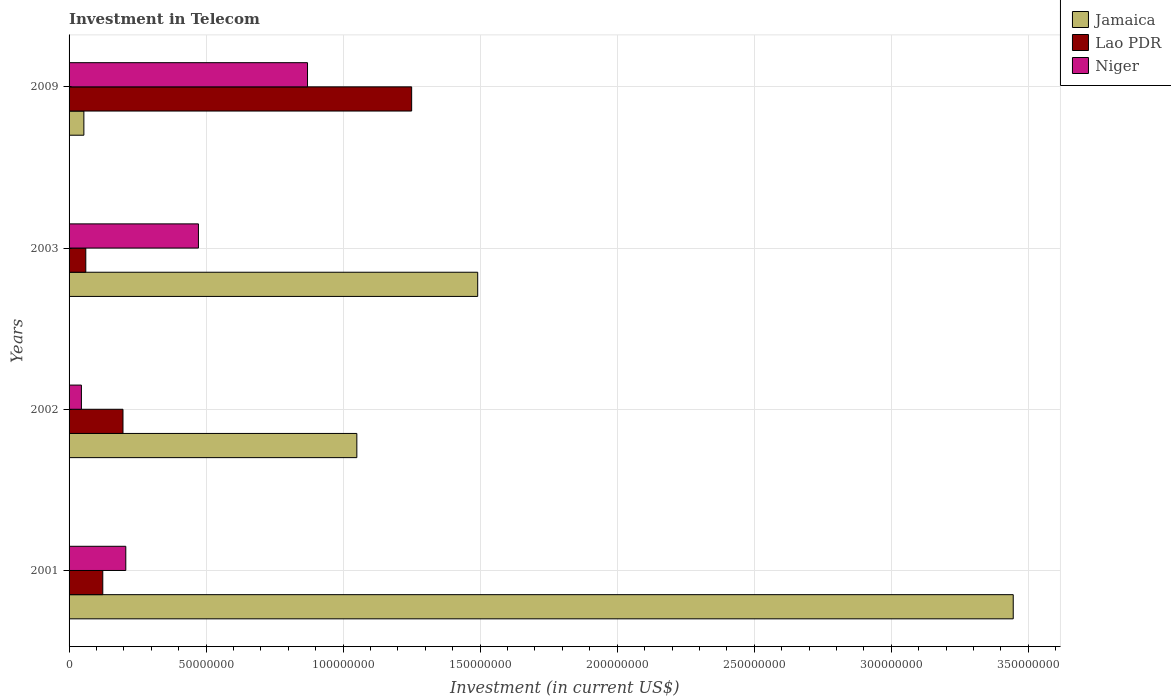How many groups of bars are there?
Keep it short and to the point. 4. How many bars are there on the 1st tick from the top?
Your answer should be very brief. 3. How many bars are there on the 1st tick from the bottom?
Your response must be concise. 3. What is the amount invested in telecom in Niger in 2002?
Make the answer very short. 4.50e+06. Across all years, what is the maximum amount invested in telecom in Jamaica?
Ensure brevity in your answer.  3.44e+08. Across all years, what is the minimum amount invested in telecom in Lao PDR?
Provide a succinct answer. 6.10e+06. What is the total amount invested in telecom in Jamaica in the graph?
Your answer should be very brief. 6.04e+08. What is the difference between the amount invested in telecom in Niger in 2001 and that in 2002?
Make the answer very short. 1.62e+07. What is the difference between the amount invested in telecom in Niger in 2001 and the amount invested in telecom in Lao PDR in 2003?
Provide a short and direct response. 1.46e+07. What is the average amount invested in telecom in Lao PDR per year?
Make the answer very short. 4.08e+07. In the year 2001, what is the difference between the amount invested in telecom in Jamaica and amount invested in telecom in Niger?
Ensure brevity in your answer.  3.24e+08. What is the ratio of the amount invested in telecom in Niger in 2002 to that in 2003?
Make the answer very short. 0.1. Is the amount invested in telecom in Jamaica in 2002 less than that in 2003?
Ensure brevity in your answer.  Yes. What is the difference between the highest and the second highest amount invested in telecom in Niger?
Offer a very short reply. 3.98e+07. What is the difference between the highest and the lowest amount invested in telecom in Niger?
Offer a terse response. 8.25e+07. In how many years, is the amount invested in telecom in Jamaica greater than the average amount invested in telecom in Jamaica taken over all years?
Your response must be concise. 1. Is the sum of the amount invested in telecom in Jamaica in 2001 and 2003 greater than the maximum amount invested in telecom in Lao PDR across all years?
Your answer should be very brief. Yes. What does the 2nd bar from the top in 2003 represents?
Provide a short and direct response. Lao PDR. What does the 2nd bar from the bottom in 2001 represents?
Make the answer very short. Lao PDR. Are all the bars in the graph horizontal?
Your answer should be very brief. Yes. Are the values on the major ticks of X-axis written in scientific E-notation?
Your answer should be very brief. No. Does the graph contain grids?
Give a very brief answer. Yes. What is the title of the graph?
Keep it short and to the point. Investment in Telecom. Does "Singapore" appear as one of the legend labels in the graph?
Offer a very short reply. No. What is the label or title of the X-axis?
Your answer should be compact. Investment (in current US$). What is the Investment (in current US$) in Jamaica in 2001?
Your response must be concise. 3.44e+08. What is the Investment (in current US$) of Lao PDR in 2001?
Provide a succinct answer. 1.23e+07. What is the Investment (in current US$) of Niger in 2001?
Give a very brief answer. 2.07e+07. What is the Investment (in current US$) of Jamaica in 2002?
Give a very brief answer. 1.05e+08. What is the Investment (in current US$) in Lao PDR in 2002?
Provide a succinct answer. 1.97e+07. What is the Investment (in current US$) in Niger in 2002?
Keep it short and to the point. 4.50e+06. What is the Investment (in current US$) of Jamaica in 2003?
Ensure brevity in your answer.  1.49e+08. What is the Investment (in current US$) in Lao PDR in 2003?
Provide a short and direct response. 6.10e+06. What is the Investment (in current US$) in Niger in 2003?
Provide a short and direct response. 4.72e+07. What is the Investment (in current US$) of Jamaica in 2009?
Your answer should be very brief. 5.40e+06. What is the Investment (in current US$) of Lao PDR in 2009?
Your response must be concise. 1.25e+08. What is the Investment (in current US$) of Niger in 2009?
Offer a terse response. 8.70e+07. Across all years, what is the maximum Investment (in current US$) in Jamaica?
Your response must be concise. 3.44e+08. Across all years, what is the maximum Investment (in current US$) in Lao PDR?
Your response must be concise. 1.25e+08. Across all years, what is the maximum Investment (in current US$) in Niger?
Ensure brevity in your answer.  8.70e+07. Across all years, what is the minimum Investment (in current US$) in Jamaica?
Your response must be concise. 5.40e+06. Across all years, what is the minimum Investment (in current US$) of Lao PDR?
Give a very brief answer. 6.10e+06. Across all years, what is the minimum Investment (in current US$) in Niger?
Keep it short and to the point. 4.50e+06. What is the total Investment (in current US$) of Jamaica in the graph?
Give a very brief answer. 6.04e+08. What is the total Investment (in current US$) of Lao PDR in the graph?
Your answer should be very brief. 1.63e+08. What is the total Investment (in current US$) in Niger in the graph?
Make the answer very short. 1.59e+08. What is the difference between the Investment (in current US$) in Jamaica in 2001 and that in 2002?
Give a very brief answer. 2.40e+08. What is the difference between the Investment (in current US$) of Lao PDR in 2001 and that in 2002?
Your answer should be compact. -7.37e+06. What is the difference between the Investment (in current US$) of Niger in 2001 and that in 2002?
Provide a succinct answer. 1.62e+07. What is the difference between the Investment (in current US$) in Jamaica in 2001 and that in 2003?
Make the answer very short. 1.95e+08. What is the difference between the Investment (in current US$) in Lao PDR in 2001 and that in 2003?
Provide a succinct answer. 6.20e+06. What is the difference between the Investment (in current US$) in Niger in 2001 and that in 2003?
Make the answer very short. -2.65e+07. What is the difference between the Investment (in current US$) of Jamaica in 2001 and that in 2009?
Offer a terse response. 3.39e+08. What is the difference between the Investment (in current US$) of Lao PDR in 2001 and that in 2009?
Offer a terse response. -1.13e+08. What is the difference between the Investment (in current US$) in Niger in 2001 and that in 2009?
Your answer should be very brief. -6.63e+07. What is the difference between the Investment (in current US$) of Jamaica in 2002 and that in 2003?
Your response must be concise. -4.41e+07. What is the difference between the Investment (in current US$) in Lao PDR in 2002 and that in 2003?
Offer a very short reply. 1.36e+07. What is the difference between the Investment (in current US$) of Niger in 2002 and that in 2003?
Keep it short and to the point. -4.27e+07. What is the difference between the Investment (in current US$) in Jamaica in 2002 and that in 2009?
Give a very brief answer. 9.96e+07. What is the difference between the Investment (in current US$) of Lao PDR in 2002 and that in 2009?
Make the answer very short. -1.05e+08. What is the difference between the Investment (in current US$) in Niger in 2002 and that in 2009?
Keep it short and to the point. -8.25e+07. What is the difference between the Investment (in current US$) of Jamaica in 2003 and that in 2009?
Ensure brevity in your answer.  1.44e+08. What is the difference between the Investment (in current US$) in Lao PDR in 2003 and that in 2009?
Your answer should be very brief. -1.19e+08. What is the difference between the Investment (in current US$) of Niger in 2003 and that in 2009?
Provide a short and direct response. -3.98e+07. What is the difference between the Investment (in current US$) in Jamaica in 2001 and the Investment (in current US$) in Lao PDR in 2002?
Ensure brevity in your answer.  3.25e+08. What is the difference between the Investment (in current US$) of Jamaica in 2001 and the Investment (in current US$) of Niger in 2002?
Provide a succinct answer. 3.40e+08. What is the difference between the Investment (in current US$) of Lao PDR in 2001 and the Investment (in current US$) of Niger in 2002?
Provide a short and direct response. 7.80e+06. What is the difference between the Investment (in current US$) of Jamaica in 2001 and the Investment (in current US$) of Lao PDR in 2003?
Give a very brief answer. 3.38e+08. What is the difference between the Investment (in current US$) of Jamaica in 2001 and the Investment (in current US$) of Niger in 2003?
Your answer should be compact. 2.97e+08. What is the difference between the Investment (in current US$) in Lao PDR in 2001 and the Investment (in current US$) in Niger in 2003?
Keep it short and to the point. -3.49e+07. What is the difference between the Investment (in current US$) of Jamaica in 2001 and the Investment (in current US$) of Lao PDR in 2009?
Provide a succinct answer. 2.20e+08. What is the difference between the Investment (in current US$) in Jamaica in 2001 and the Investment (in current US$) in Niger in 2009?
Offer a terse response. 2.58e+08. What is the difference between the Investment (in current US$) of Lao PDR in 2001 and the Investment (in current US$) of Niger in 2009?
Give a very brief answer. -7.47e+07. What is the difference between the Investment (in current US$) in Jamaica in 2002 and the Investment (in current US$) in Lao PDR in 2003?
Offer a very short reply. 9.89e+07. What is the difference between the Investment (in current US$) in Jamaica in 2002 and the Investment (in current US$) in Niger in 2003?
Your answer should be compact. 5.78e+07. What is the difference between the Investment (in current US$) in Lao PDR in 2002 and the Investment (in current US$) in Niger in 2003?
Your answer should be very brief. -2.75e+07. What is the difference between the Investment (in current US$) of Jamaica in 2002 and the Investment (in current US$) of Lao PDR in 2009?
Make the answer very short. -2.00e+07. What is the difference between the Investment (in current US$) of Jamaica in 2002 and the Investment (in current US$) of Niger in 2009?
Your answer should be compact. 1.80e+07. What is the difference between the Investment (in current US$) of Lao PDR in 2002 and the Investment (in current US$) of Niger in 2009?
Your answer should be compact. -6.73e+07. What is the difference between the Investment (in current US$) in Jamaica in 2003 and the Investment (in current US$) in Lao PDR in 2009?
Provide a succinct answer. 2.41e+07. What is the difference between the Investment (in current US$) in Jamaica in 2003 and the Investment (in current US$) in Niger in 2009?
Provide a short and direct response. 6.21e+07. What is the difference between the Investment (in current US$) in Lao PDR in 2003 and the Investment (in current US$) in Niger in 2009?
Offer a very short reply. -8.09e+07. What is the average Investment (in current US$) of Jamaica per year?
Your answer should be compact. 1.51e+08. What is the average Investment (in current US$) in Lao PDR per year?
Keep it short and to the point. 4.08e+07. What is the average Investment (in current US$) in Niger per year?
Offer a very short reply. 3.98e+07. In the year 2001, what is the difference between the Investment (in current US$) in Jamaica and Investment (in current US$) in Lao PDR?
Your answer should be compact. 3.32e+08. In the year 2001, what is the difference between the Investment (in current US$) of Jamaica and Investment (in current US$) of Niger?
Make the answer very short. 3.24e+08. In the year 2001, what is the difference between the Investment (in current US$) of Lao PDR and Investment (in current US$) of Niger?
Your answer should be very brief. -8.40e+06. In the year 2002, what is the difference between the Investment (in current US$) in Jamaica and Investment (in current US$) in Lao PDR?
Ensure brevity in your answer.  8.53e+07. In the year 2002, what is the difference between the Investment (in current US$) of Jamaica and Investment (in current US$) of Niger?
Offer a very short reply. 1.00e+08. In the year 2002, what is the difference between the Investment (in current US$) of Lao PDR and Investment (in current US$) of Niger?
Your answer should be compact. 1.52e+07. In the year 2003, what is the difference between the Investment (in current US$) of Jamaica and Investment (in current US$) of Lao PDR?
Your response must be concise. 1.43e+08. In the year 2003, what is the difference between the Investment (in current US$) in Jamaica and Investment (in current US$) in Niger?
Your response must be concise. 1.02e+08. In the year 2003, what is the difference between the Investment (in current US$) of Lao PDR and Investment (in current US$) of Niger?
Your response must be concise. -4.11e+07. In the year 2009, what is the difference between the Investment (in current US$) in Jamaica and Investment (in current US$) in Lao PDR?
Ensure brevity in your answer.  -1.20e+08. In the year 2009, what is the difference between the Investment (in current US$) in Jamaica and Investment (in current US$) in Niger?
Ensure brevity in your answer.  -8.16e+07. In the year 2009, what is the difference between the Investment (in current US$) of Lao PDR and Investment (in current US$) of Niger?
Provide a short and direct response. 3.80e+07. What is the ratio of the Investment (in current US$) of Jamaica in 2001 to that in 2002?
Provide a succinct answer. 3.28. What is the ratio of the Investment (in current US$) in Lao PDR in 2001 to that in 2002?
Your answer should be compact. 0.63. What is the ratio of the Investment (in current US$) in Jamaica in 2001 to that in 2003?
Offer a terse response. 2.31. What is the ratio of the Investment (in current US$) in Lao PDR in 2001 to that in 2003?
Make the answer very short. 2.02. What is the ratio of the Investment (in current US$) in Niger in 2001 to that in 2003?
Your answer should be very brief. 0.44. What is the ratio of the Investment (in current US$) of Jamaica in 2001 to that in 2009?
Your response must be concise. 63.8. What is the ratio of the Investment (in current US$) in Lao PDR in 2001 to that in 2009?
Give a very brief answer. 0.1. What is the ratio of the Investment (in current US$) in Niger in 2001 to that in 2009?
Give a very brief answer. 0.24. What is the ratio of the Investment (in current US$) of Jamaica in 2002 to that in 2003?
Your answer should be compact. 0.7. What is the ratio of the Investment (in current US$) in Lao PDR in 2002 to that in 2003?
Make the answer very short. 3.22. What is the ratio of the Investment (in current US$) in Niger in 2002 to that in 2003?
Make the answer very short. 0.1. What is the ratio of the Investment (in current US$) in Jamaica in 2002 to that in 2009?
Your answer should be compact. 19.44. What is the ratio of the Investment (in current US$) of Lao PDR in 2002 to that in 2009?
Keep it short and to the point. 0.16. What is the ratio of the Investment (in current US$) in Niger in 2002 to that in 2009?
Give a very brief answer. 0.05. What is the ratio of the Investment (in current US$) in Jamaica in 2003 to that in 2009?
Provide a short and direct response. 27.61. What is the ratio of the Investment (in current US$) of Lao PDR in 2003 to that in 2009?
Give a very brief answer. 0.05. What is the ratio of the Investment (in current US$) in Niger in 2003 to that in 2009?
Offer a terse response. 0.54. What is the difference between the highest and the second highest Investment (in current US$) in Jamaica?
Provide a succinct answer. 1.95e+08. What is the difference between the highest and the second highest Investment (in current US$) of Lao PDR?
Your answer should be very brief. 1.05e+08. What is the difference between the highest and the second highest Investment (in current US$) of Niger?
Ensure brevity in your answer.  3.98e+07. What is the difference between the highest and the lowest Investment (in current US$) in Jamaica?
Offer a very short reply. 3.39e+08. What is the difference between the highest and the lowest Investment (in current US$) in Lao PDR?
Provide a succinct answer. 1.19e+08. What is the difference between the highest and the lowest Investment (in current US$) in Niger?
Your answer should be very brief. 8.25e+07. 